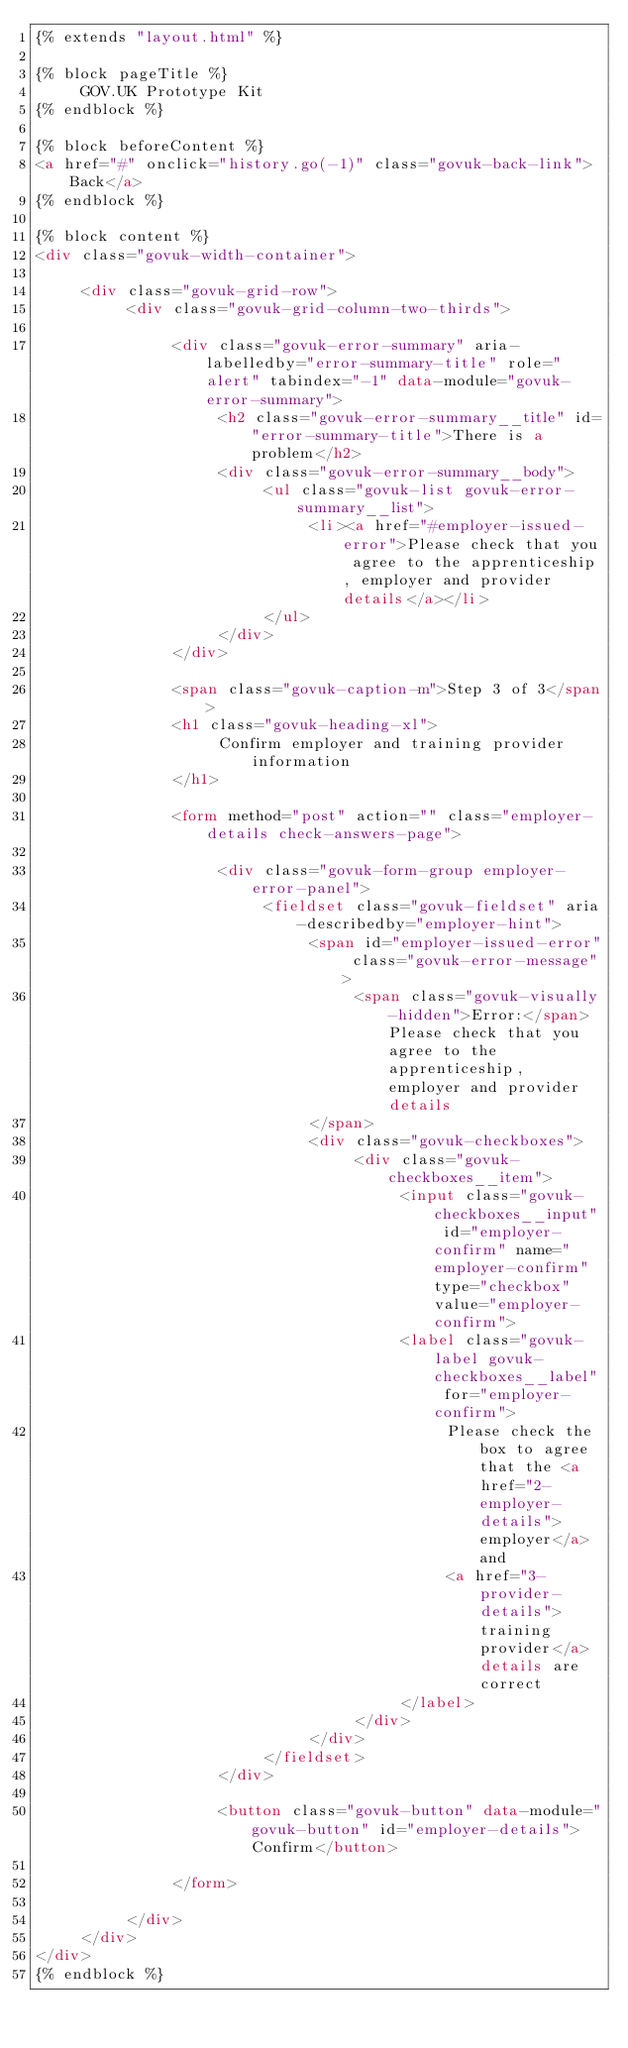Convert code to text. <code><loc_0><loc_0><loc_500><loc_500><_HTML_>{% extends "layout.html" %}

{% block pageTitle %}
     GOV.UK Prototype Kit
{% endblock %}

{% block beforeContent %}
<a href="#" onclick="history.go(-1)" class="govuk-back-link">Back</a>
{% endblock %}

{% block content %}
<div class="govuk-width-container">

     <div class="govuk-grid-row">
          <div class="govuk-grid-column-two-thirds">

               <div class="govuk-error-summary" aria-labelledby="error-summary-title" role="alert" tabindex="-1" data-module="govuk-error-summary">
                    <h2 class="govuk-error-summary__title" id="error-summary-title">There is a problem</h2>
                    <div class="govuk-error-summary__body">
                         <ul class="govuk-list govuk-error-summary__list">
                              <li><a href="#employer-issued-error">Please check that you agree to the apprenticeship, employer and provider details</a></li>
                         </ul>
                    </div>
               </div>

               <span class="govuk-caption-m">Step 3 of 3</span>
               <h1 class="govuk-heading-xl">
                    Confirm employer and training provider information
               </h1>

               <form method="post" action="" class="employer-details check-answers-page">

                    <div class="govuk-form-group employer-error-panel">
                         <fieldset class="govuk-fieldset" aria-describedby="employer-hint">
                              <span id="employer-issued-error" class="govuk-error-message">
                                   <span class="govuk-visually-hidden">Error:</span> Please check that you agree to the apprenticeship, employer and provider details
                              </span>
                              <div class="govuk-checkboxes">
                                   <div class="govuk-checkboxes__item">
                                        <input class="govuk-checkboxes__input" id="employer-confirm" name="employer-confirm" type="checkbox" value="employer-confirm">
                                        <label class="govuk-label govuk-checkboxes__label" for="employer-confirm">
                                             Please check the box to agree that the <a href="2-employer-details">employer</a> and
                                             <a href="3-provider-details">training provider</a> details are correct
                                        </label>
                                   </div>
                              </div>
                         </fieldset>
                    </div>

                    <button class="govuk-button" data-module="govuk-button" id="employer-details">Confirm</button>

               </form>

          </div>
     </div>
</div>
{% endblock %}
</code> 